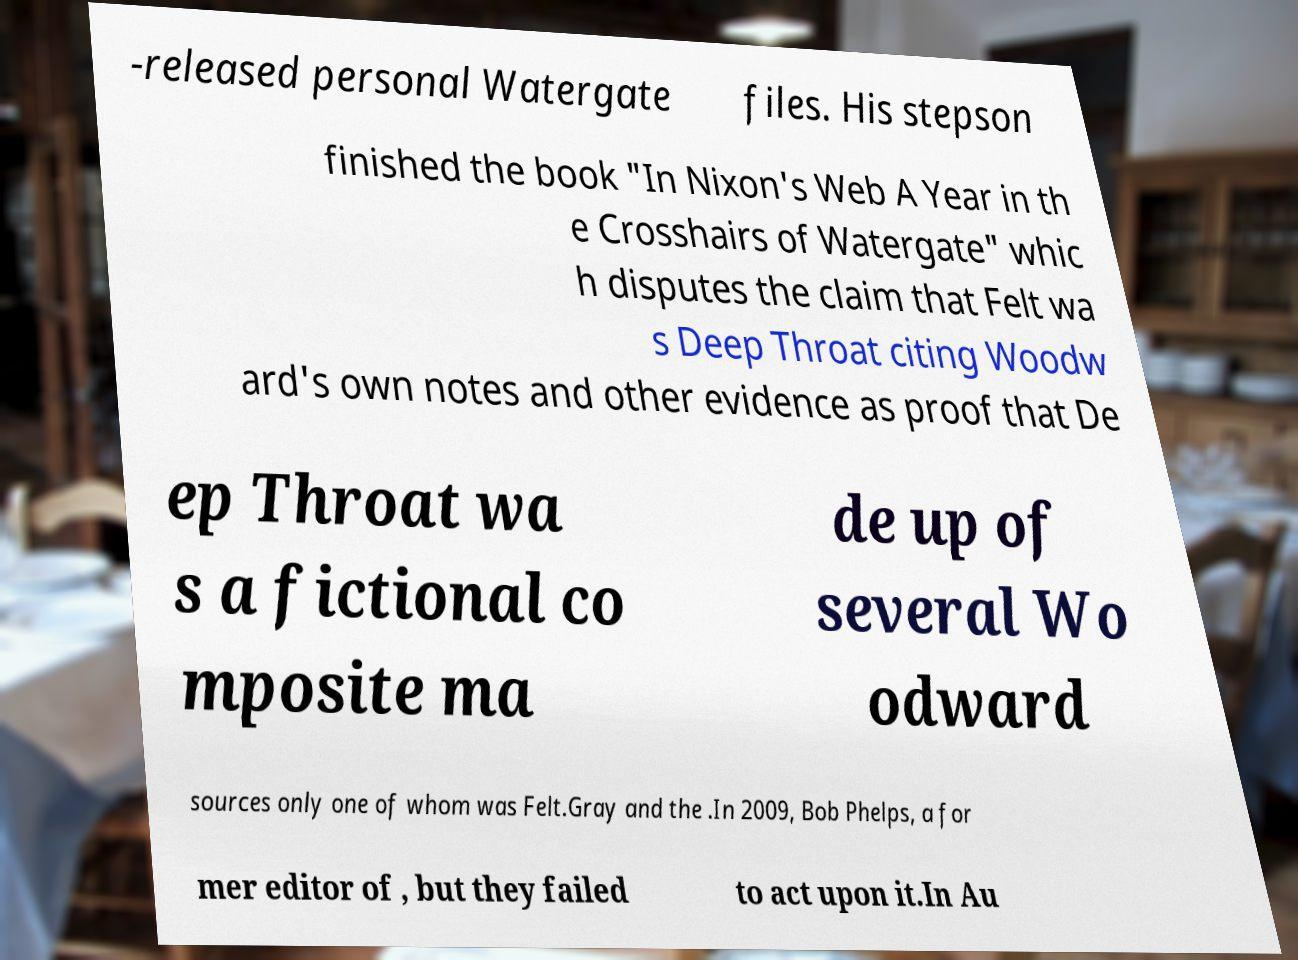Please read and relay the text visible in this image. What does it say? -released personal Watergate files. His stepson finished the book "In Nixon's Web A Year in th e Crosshairs of Watergate" whic h disputes the claim that Felt wa s Deep Throat citing Woodw ard's own notes and other evidence as proof that De ep Throat wa s a fictional co mposite ma de up of several Wo odward sources only one of whom was Felt.Gray and the .In 2009, Bob Phelps, a for mer editor of , but they failed to act upon it.In Au 